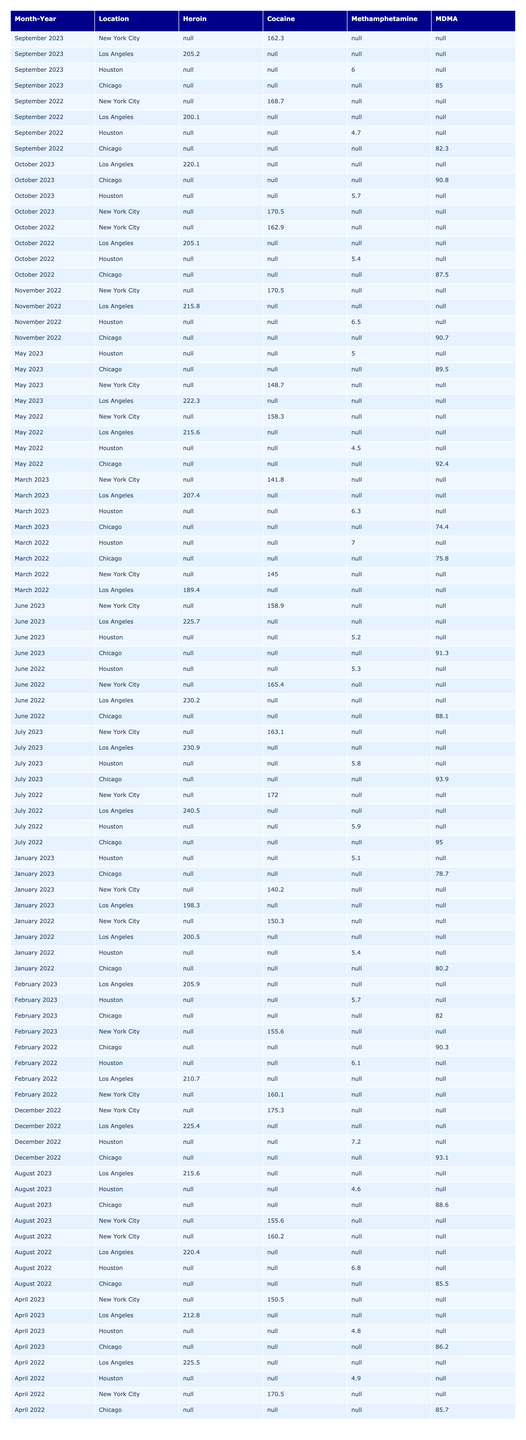What was the total quantity of cocaine seized in June 2022? In June 2022, the quantity of cocaine seized was 230.2 kg.
Answer: 230.2 kg Which month in 2022 had the highest seizure of heroin? In July 2022, the highest seizure of heroin was 172.0 kg.
Answer: July 2022 What location reported the most methamphetamine seizures in 2023? In 2023, Chicago reported the most methamphetamine seizures with values consistently around 90 kg in several months, but exact comparisons require examining the monthly amounts to confirm.
Answer: Chicago Did the amount of MDMA seized in May 2023 exceed that of April 2023? In May 2023, 5.0 kg of MDMA was seized, compared to 4.8 kg in April 2023, so yes, May had a higher amount of MDMA seized.
Answer: Yes What is the average quantity of cocaine seized per month in Los Angeles over the two years? Adding all the monthly cocaine values seized in Los Angeles (from the provided data), we get a total of 2,855.4 kg over 24 months, splitting this gives 2,855.4 kg / 24 months = approximately 119 kg.
Answer: Approximately 119 kg In September 2023, what was the seizure amount for each substance type in New York City? In September 2023, the amounts were: Heroin 162.3 kg, Cocaine 205.2 kg, Methamphetamine 85.0 kg, and MDMA 6.0 kg.
Answer: Heroin: 162.3 kg, Cocaine: 205.2 kg, Methamphetamine: 85.0 kg, MDMA: 6.0 kg What month had the lowest total seizure of all substances in 2023? To find the month with the lowest total seizure in 2023, we sum the seizures of all substances for each month and compare. January had the lowest total with 422.3 kg (140.2 kg + 198.3 kg + 78.7 kg + 5.1 kg).
Answer: January 2023 Which substance saw a decrease in seized quantity from December 2022 to January 2023? Comparing the quantities, Heroin decreased from 175.3 kg in December 2022 to 140.2 kg in January 2023.
Answer: Heroin Is it true that cocaine seizures were consistently above 200 kg from June to October 2022? Reviewing the values, cocaine in June (230.2 kg), July (240.5 kg), August (220.4 kg), September (200.1 kg), and October (205.1 kg) confirms that all these months exceeded 200 kg.
Answer: Yes What was the total seized amount of MDMA across all months in 2022? The total MDMA seized in 2022 is the sum of all monthly values: 5.4 + 6.1 + 7.0 + 4.9 + 4.5 + 5.3 + 5.9 + 6.8 + 4.7 + 5.4 + 6.5 + 7.2, which totals to 66.2 kg.
Answer: 66.2 kg Was there any month in 2022 where the seized quantity of heroin was less than 150 kg? Looking through the data, there was no month in 2022 where the quantity of heroin seized was less than 150 kg; all months reported quantities above that threshold.
Answer: No 